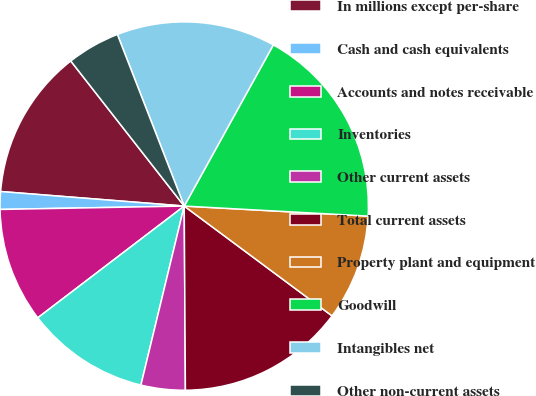Convert chart to OTSL. <chart><loc_0><loc_0><loc_500><loc_500><pie_chart><fcel>In millions except per-share<fcel>Cash and cash equivalents<fcel>Accounts and notes receivable<fcel>Inventories<fcel>Other current assets<fcel>Total current assets<fcel>Property plant and equipment<fcel>Goodwill<fcel>Intangibles net<fcel>Other non-current assets<nl><fcel>13.18%<fcel>1.55%<fcel>10.08%<fcel>10.85%<fcel>3.88%<fcel>14.73%<fcel>9.3%<fcel>17.83%<fcel>13.95%<fcel>4.65%<nl></chart> 